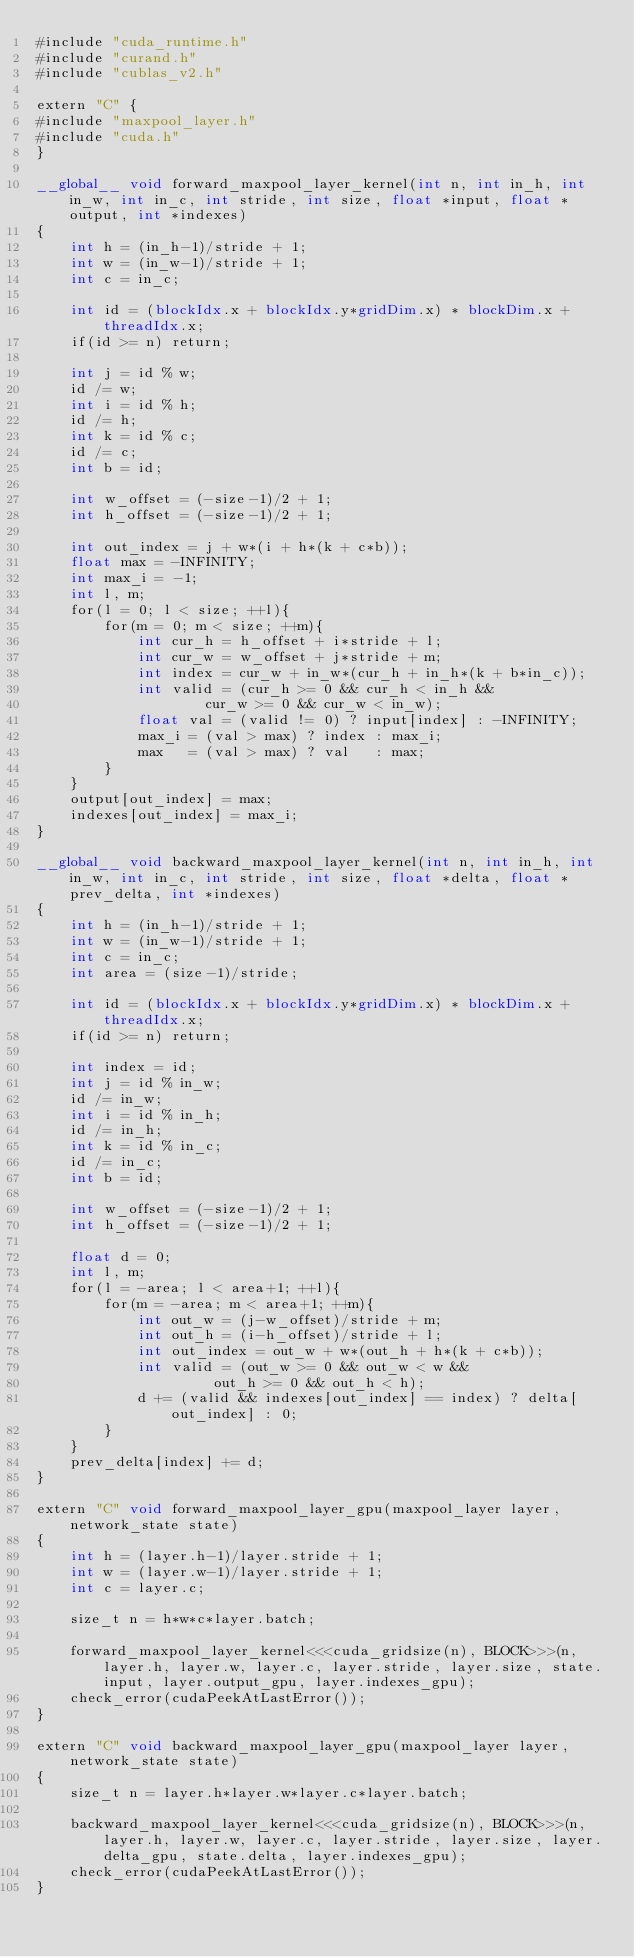<code> <loc_0><loc_0><loc_500><loc_500><_Cuda_>#include "cuda_runtime.h"
#include "curand.h"
#include "cublas_v2.h"

extern "C" {
#include "maxpool_layer.h"
#include "cuda.h"
}

__global__ void forward_maxpool_layer_kernel(int n, int in_h, int in_w, int in_c, int stride, int size, float *input, float *output, int *indexes)
{
    int h = (in_h-1)/stride + 1;
    int w = (in_w-1)/stride + 1;
    int c = in_c;

    int id = (blockIdx.x + blockIdx.y*gridDim.x) * blockDim.x + threadIdx.x;
    if(id >= n) return;

    int j = id % w;
    id /= w;
    int i = id % h;
    id /= h;
    int k = id % c;
    id /= c;
    int b = id;

    int w_offset = (-size-1)/2 + 1;
    int h_offset = (-size-1)/2 + 1;

    int out_index = j + w*(i + h*(k + c*b));
    float max = -INFINITY;
    int max_i = -1;
    int l, m;
    for(l = 0; l < size; ++l){
        for(m = 0; m < size; ++m){
            int cur_h = h_offset + i*stride + l;
            int cur_w = w_offset + j*stride + m;
            int index = cur_w + in_w*(cur_h + in_h*(k + b*in_c));
            int valid = (cur_h >= 0 && cur_h < in_h &&
                    cur_w >= 0 && cur_w < in_w);
            float val = (valid != 0) ? input[index] : -INFINITY;
            max_i = (val > max) ? index : max_i;
            max   = (val > max) ? val   : max;
        }
    }
    output[out_index] = max;
    indexes[out_index] = max_i;
}

__global__ void backward_maxpool_layer_kernel(int n, int in_h, int in_w, int in_c, int stride, int size, float *delta, float *prev_delta, int *indexes)
{
    int h = (in_h-1)/stride + 1;
    int w = (in_w-1)/stride + 1;
    int c = in_c;
    int area = (size-1)/stride;

    int id = (blockIdx.x + blockIdx.y*gridDim.x) * blockDim.x + threadIdx.x;
    if(id >= n) return;

    int index = id;
    int j = id % in_w;
    id /= in_w;
    int i = id % in_h;
    id /= in_h;
    int k = id % in_c;
    id /= in_c;
    int b = id;

    int w_offset = (-size-1)/2 + 1;
    int h_offset = (-size-1)/2 + 1;

    float d = 0;
    int l, m;
    for(l = -area; l < area+1; ++l){
        for(m = -area; m < area+1; ++m){
            int out_w = (j-w_offset)/stride + m;
            int out_h = (i-h_offset)/stride + l;
            int out_index = out_w + w*(out_h + h*(k + c*b));
            int valid = (out_w >= 0 && out_w < w &&
                     out_h >= 0 && out_h < h);
            d += (valid && indexes[out_index] == index) ? delta[out_index] : 0;
        }
    }
    prev_delta[index] += d;
}

extern "C" void forward_maxpool_layer_gpu(maxpool_layer layer, network_state state)
{
    int h = (layer.h-1)/layer.stride + 1;
    int w = (layer.w-1)/layer.stride + 1;
    int c = layer.c;

    size_t n = h*w*c*layer.batch;

    forward_maxpool_layer_kernel<<<cuda_gridsize(n), BLOCK>>>(n, layer.h, layer.w, layer.c, layer.stride, layer.size, state.input, layer.output_gpu, layer.indexes_gpu);
    check_error(cudaPeekAtLastError());
}

extern "C" void backward_maxpool_layer_gpu(maxpool_layer layer, network_state state)
{
    size_t n = layer.h*layer.w*layer.c*layer.batch;

    backward_maxpool_layer_kernel<<<cuda_gridsize(n), BLOCK>>>(n, layer.h, layer.w, layer.c, layer.stride, layer.size, layer.delta_gpu, state.delta, layer.indexes_gpu);
    check_error(cudaPeekAtLastError());
}

</code> 